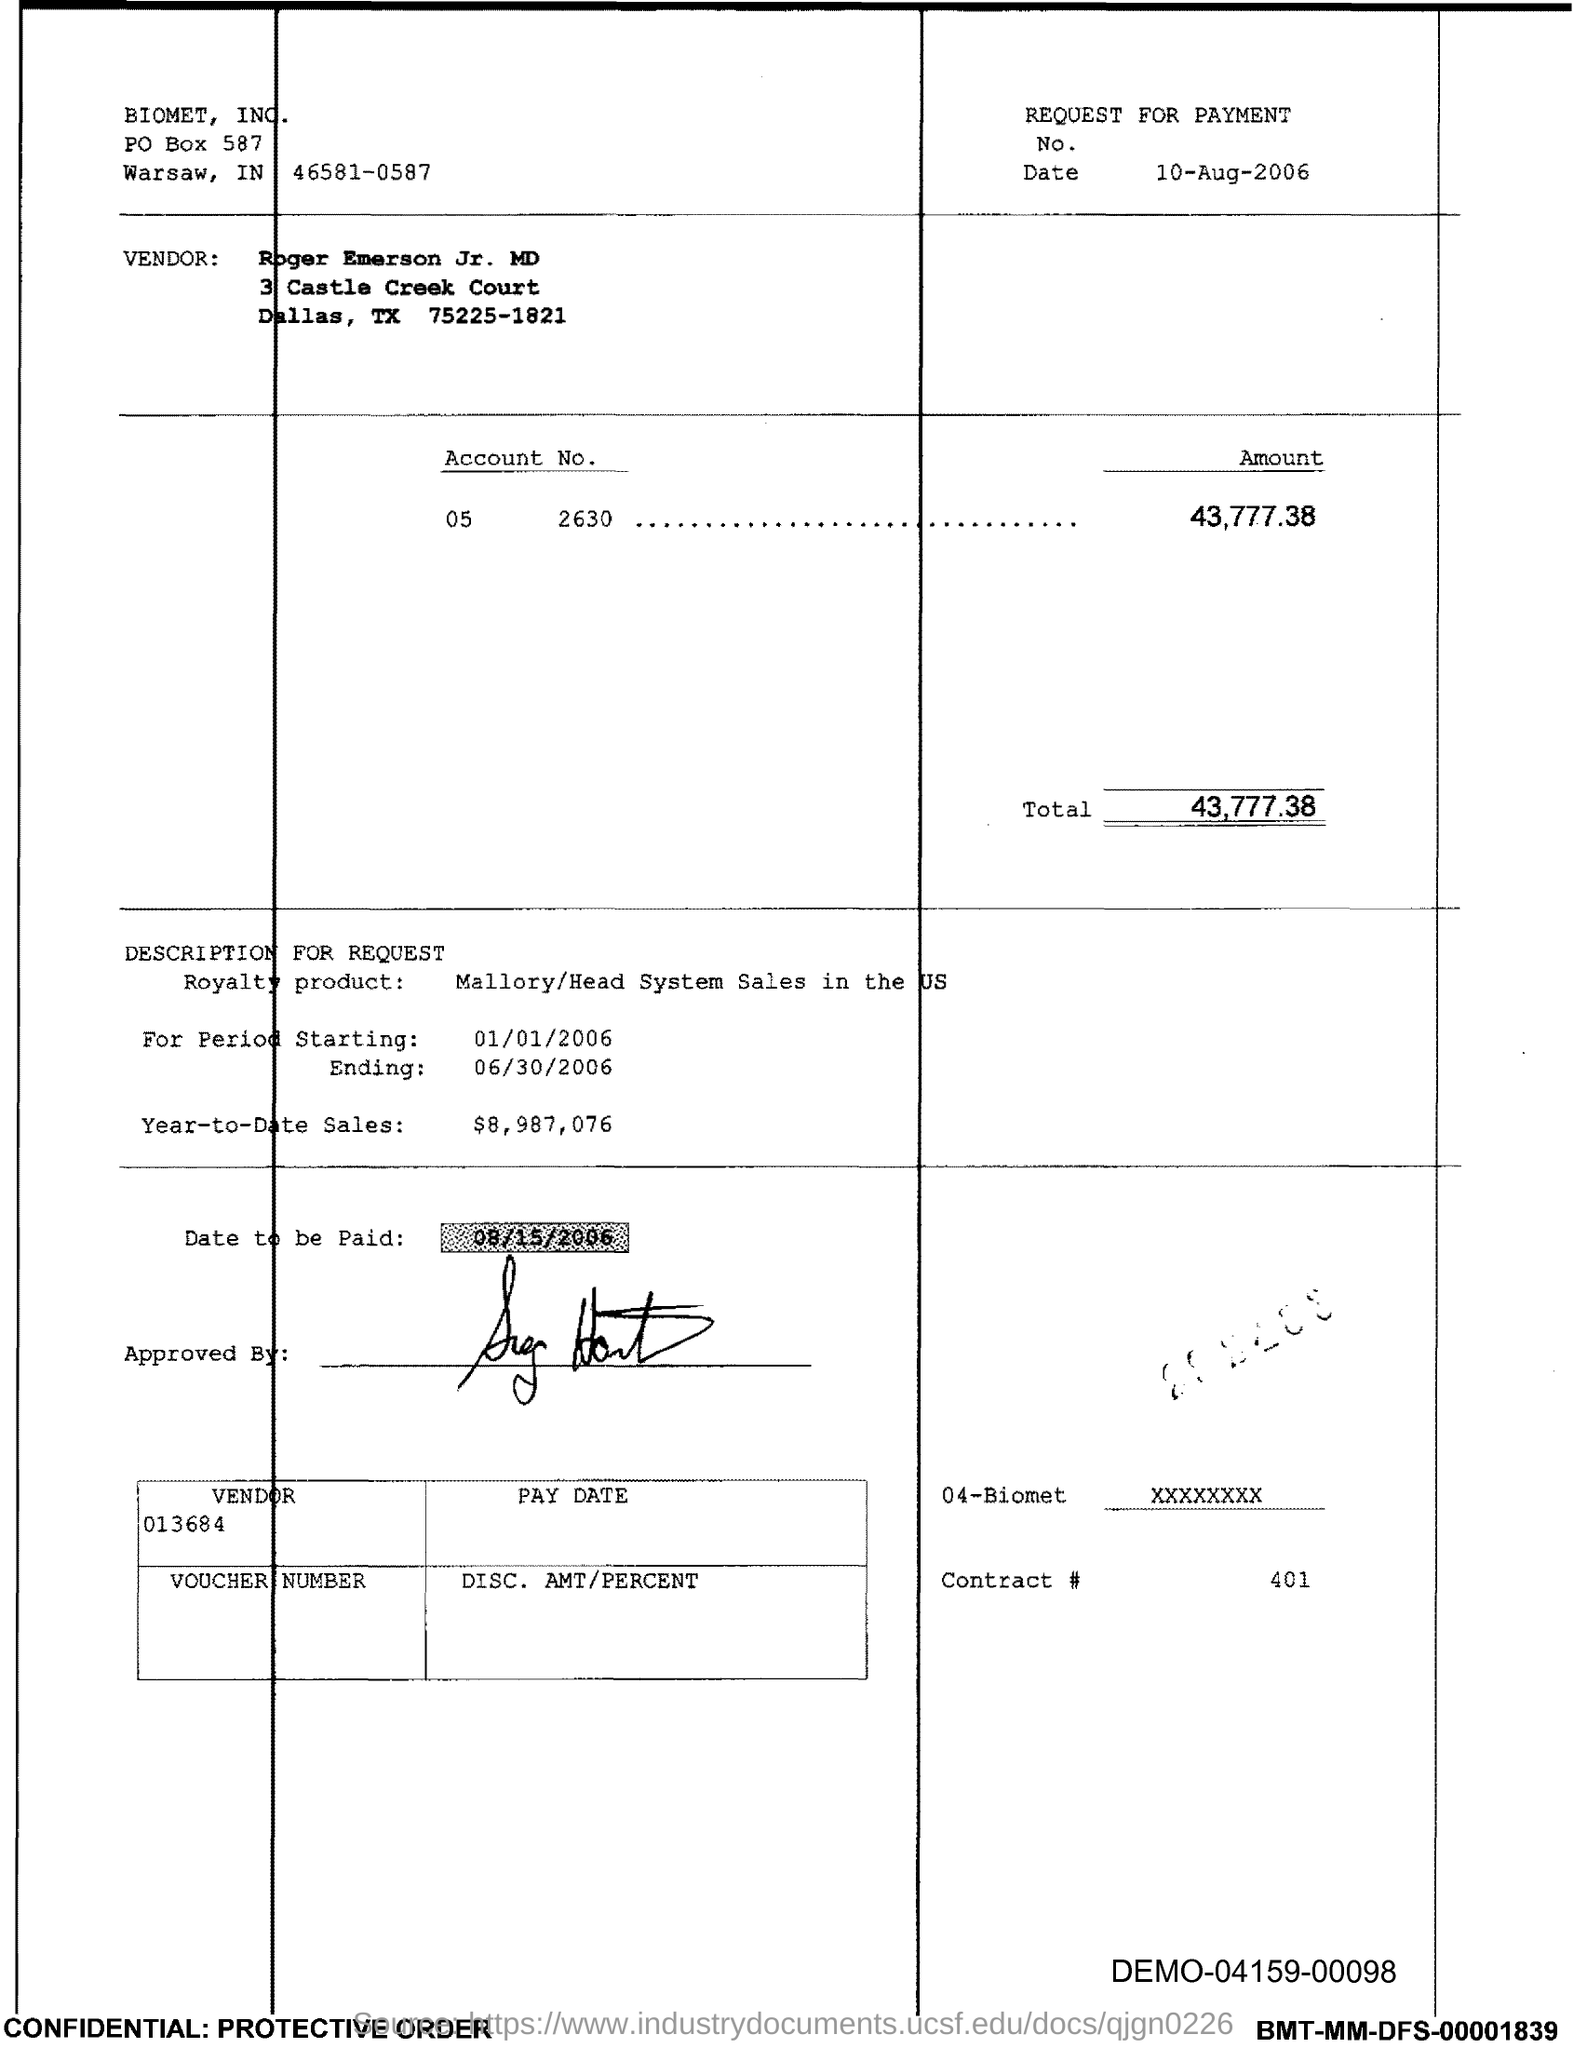What is the issued date of this voucher?
Your response must be concise. 10-Aug-2006. What is the vendor name given in the voucher?
Your answer should be compact. Roger Emerson Jr. MD. What is the Account No. given in the voucher?
Provide a short and direct response. 2630. What is the total amount mentioned in the voucher?
Your answer should be compact. 43,777.38. What is the royalty product given in the voucher?
Give a very brief answer. Mallory/Head System Sales in the US. What is the Year-to-Date Sales of the royalty product?
Offer a terse response. $8,987,076. What is the start date of the royalty period?
Offer a very short reply. 01/01/2006. What is the Contract # given in the voucher?
Provide a succinct answer. 401. What is the end date of the royalty period?
Make the answer very short. 06/30/2006. 